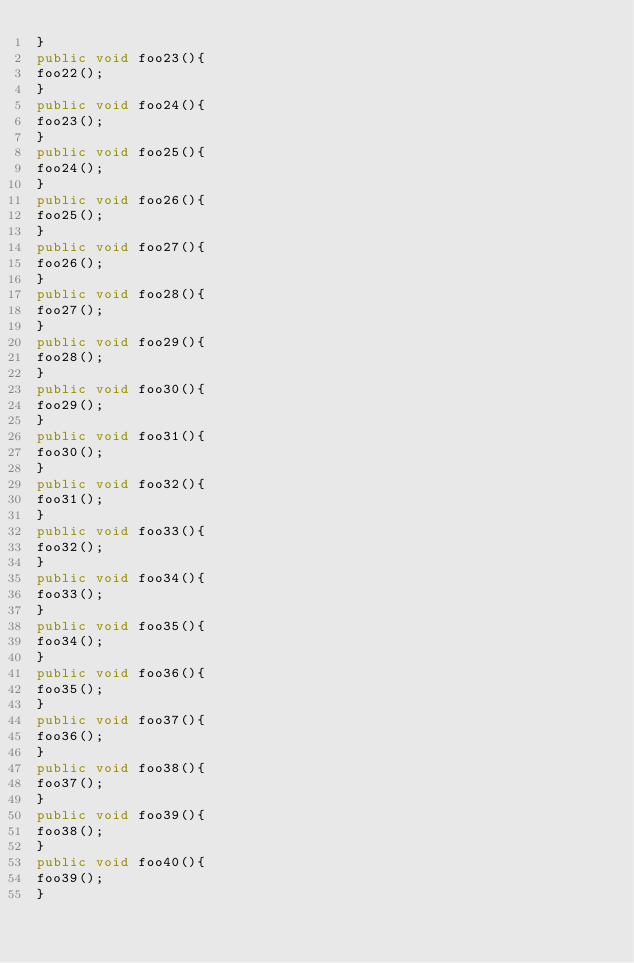<code> <loc_0><loc_0><loc_500><loc_500><_Java_>}
public void foo23(){
foo22();
}
public void foo24(){
foo23();
}
public void foo25(){
foo24();
}
public void foo26(){
foo25();
}
public void foo27(){
foo26();
}
public void foo28(){
foo27();
}
public void foo29(){
foo28();
}
public void foo30(){
foo29();
}
public void foo31(){
foo30();
}
public void foo32(){
foo31();
}
public void foo33(){
foo32();
}
public void foo34(){
foo33();
}
public void foo35(){
foo34();
}
public void foo36(){
foo35();
}
public void foo37(){
foo36();
}
public void foo38(){
foo37();
}
public void foo39(){
foo38();
}
public void foo40(){
foo39();
}</code> 